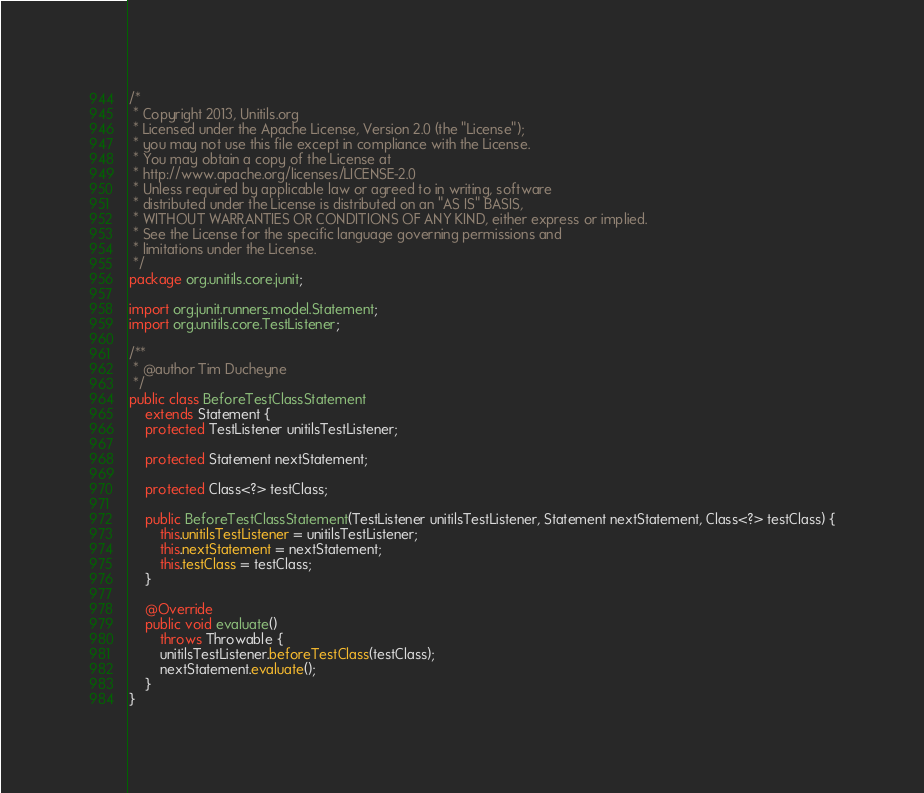<code> <loc_0><loc_0><loc_500><loc_500><_Java_>/*
 * Copyright 2013, Unitils.org
 * Licensed under the Apache License, Version 2.0 (the "License");
 * you may not use this file except in compliance with the License.
 * You may obtain a copy of the License at
 * http://www.apache.org/licenses/LICENSE-2.0
 * Unless required by applicable law or agreed to in writing, software
 * distributed under the License is distributed on an "AS IS" BASIS,
 * WITHOUT WARRANTIES OR CONDITIONS OF ANY KIND, either express or implied.
 * See the License for the specific language governing permissions and
 * limitations under the License.
 */
package org.unitils.core.junit;

import org.junit.runners.model.Statement;
import org.unitils.core.TestListener;

/**
 * @author Tim Ducheyne
 */
public class BeforeTestClassStatement
    extends Statement {
    protected TestListener unitilsTestListener;

    protected Statement nextStatement;

    protected Class<?> testClass;

    public BeforeTestClassStatement(TestListener unitilsTestListener, Statement nextStatement, Class<?> testClass) {
        this.unitilsTestListener = unitilsTestListener;
        this.nextStatement = nextStatement;
        this.testClass = testClass;
    }

    @Override
    public void evaluate()
        throws Throwable {
        unitilsTestListener.beforeTestClass(testClass);
        nextStatement.evaluate();
    }
}
</code> 